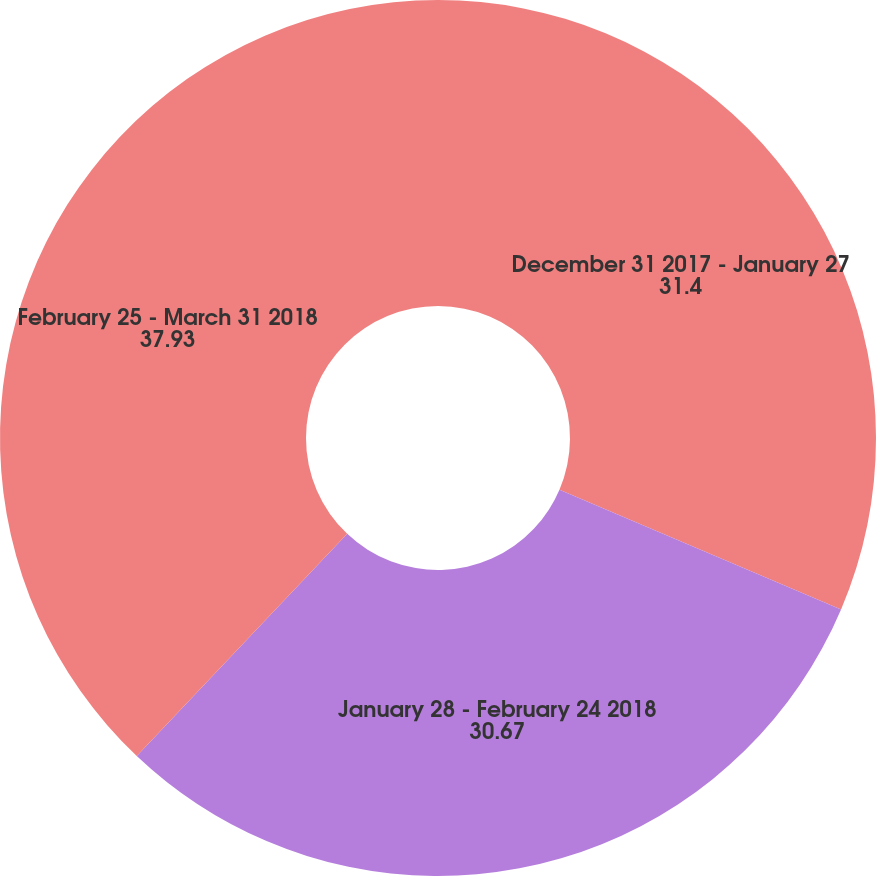Convert chart. <chart><loc_0><loc_0><loc_500><loc_500><pie_chart><fcel>December 31 2017 - January 27<fcel>January 28 - February 24 2018<fcel>February 25 - March 31 2018<nl><fcel>31.4%<fcel>30.67%<fcel>37.93%<nl></chart> 